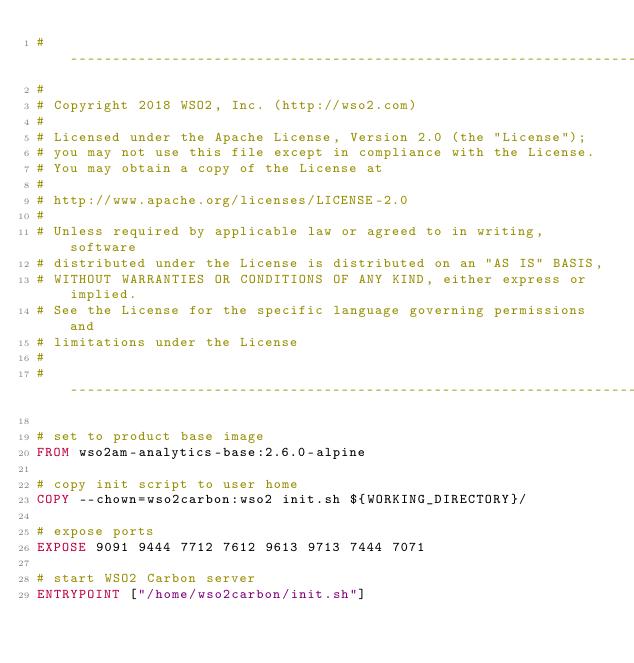<code> <loc_0><loc_0><loc_500><loc_500><_Dockerfile_># ------------------------------------------------------------------------
#
# Copyright 2018 WSO2, Inc. (http://wso2.com)
#
# Licensed under the Apache License, Version 2.0 (the "License");
# you may not use this file except in compliance with the License.
# You may obtain a copy of the License at
#
# http://www.apache.org/licenses/LICENSE-2.0
#
# Unless required by applicable law or agreed to in writing, software
# distributed under the License is distributed on an "AS IS" BASIS,
# WITHOUT WARRANTIES OR CONDITIONS OF ANY KIND, either express or implied.
# See the License for the specific language governing permissions and
# limitations under the License
#
# ------------------------------------------------------------------------

# set to product base image
FROM wso2am-analytics-base:2.6.0-alpine

# copy init script to user home
COPY --chown=wso2carbon:wso2 init.sh ${WORKING_DIRECTORY}/

# expose ports
EXPOSE 9091 9444 7712 7612 9613 9713 7444 7071

# start WSO2 Carbon server
ENTRYPOINT ["/home/wso2carbon/init.sh"]
</code> 